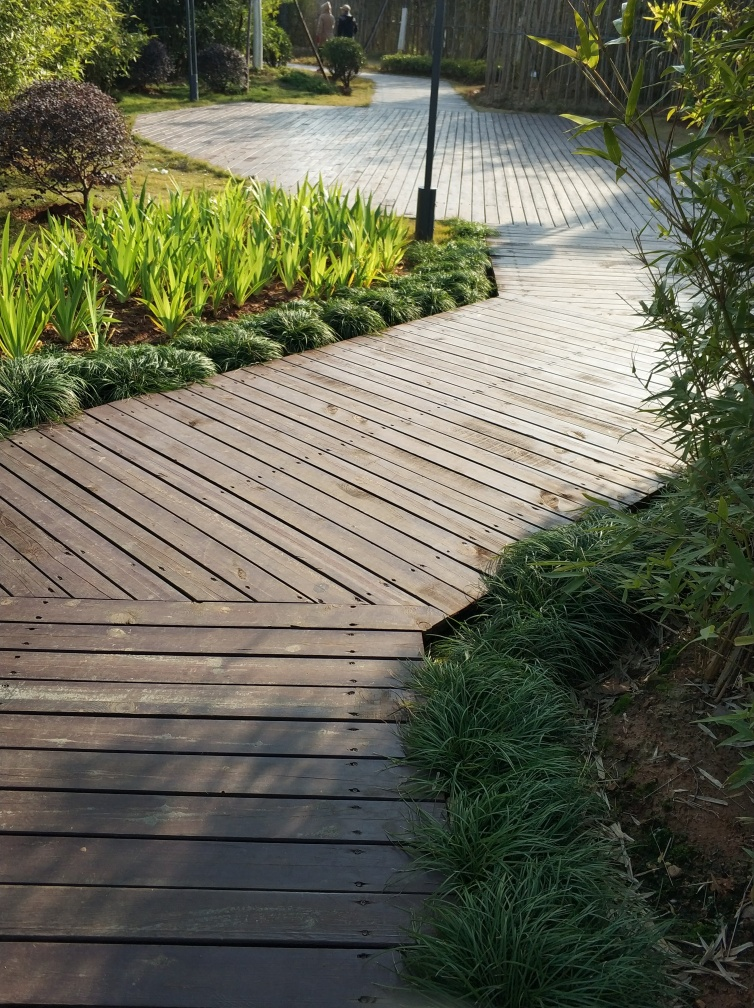Can you describe the landscaping style shown in the image? The landscaping style in the image is well-manicured and organized. There is a wooden boardwalk that meanders through the green space, with neatly placed grass and ornamental plants on both sides. The design appears to be a fusion of formal and informal styles, combining the structured arrangement of vegetation with the natural, winding path. 